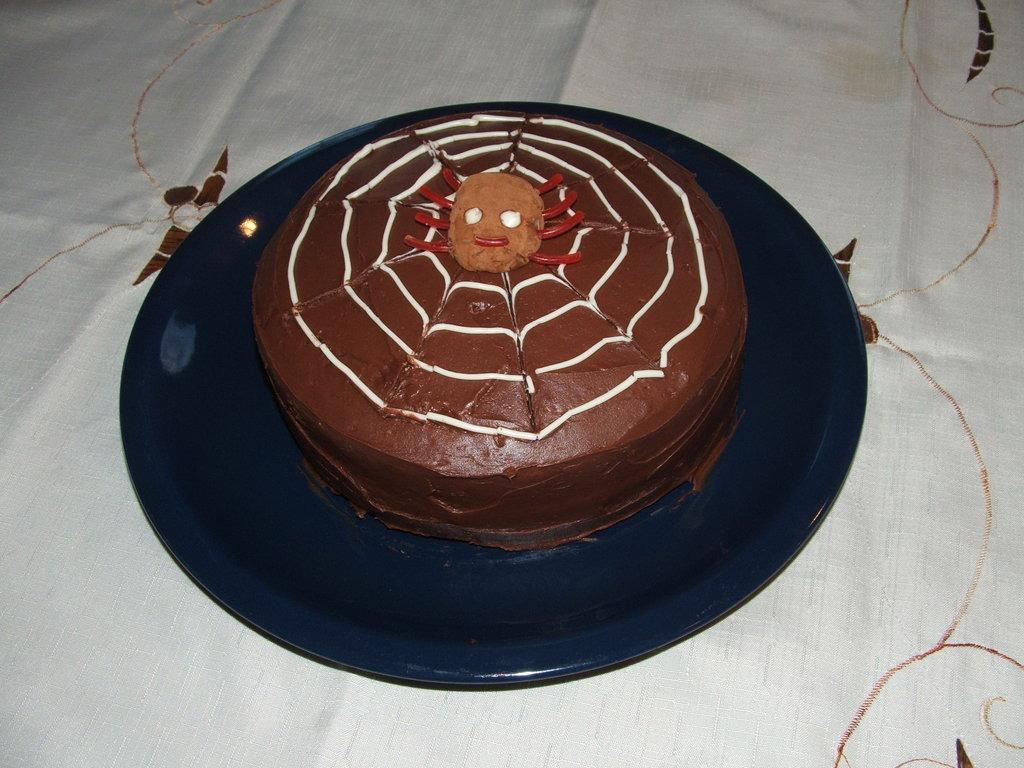Can you describe this image briefly? This image consists of a cake is kept on a blue color plate. The plate is on the table which is covered with white cloth. 